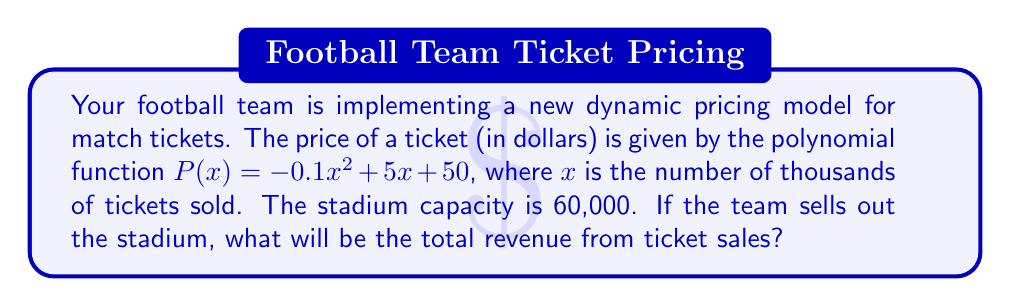Help me with this question. To solve this problem, we need to follow these steps:

1) First, we need to determine the value of $x$ when the stadium is sold out. Since $x$ represents thousands of tickets, and the capacity is 60,000:

   $x = 60,000 \div 1,000 = 60$

2) Now, we need to calculate the price of a ticket when $x = 60$:

   $P(60) = -0.1(60)^2 + 5(60) + 50$
   $= -0.1(3600) + 300 + 50$
   $= -360 + 300 + 50$
   $= -10$

3) However, since ticket prices can't be negative, we'll assume there's a minimum price of $50. So the actual price will be $50.

4) To calculate the total revenue, we multiply the number of tickets sold by the price per ticket:

   Total Revenue $= 60,000 \times \$50 = \$3,000,000$

Therefore, the total revenue from ticket sales when the stadium is sold out will be $3,000,000.
Answer: $3,000,000 